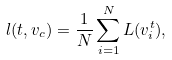Convert formula to latex. <formula><loc_0><loc_0><loc_500><loc_500>l ( t , v _ { c } ) = \frac { 1 } { N } \sum _ { i = 1 } ^ { N } L ( v _ { i } ^ { t } ) ,</formula> 